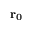<formula> <loc_0><loc_0><loc_500><loc_500>r _ { 0 }</formula> 